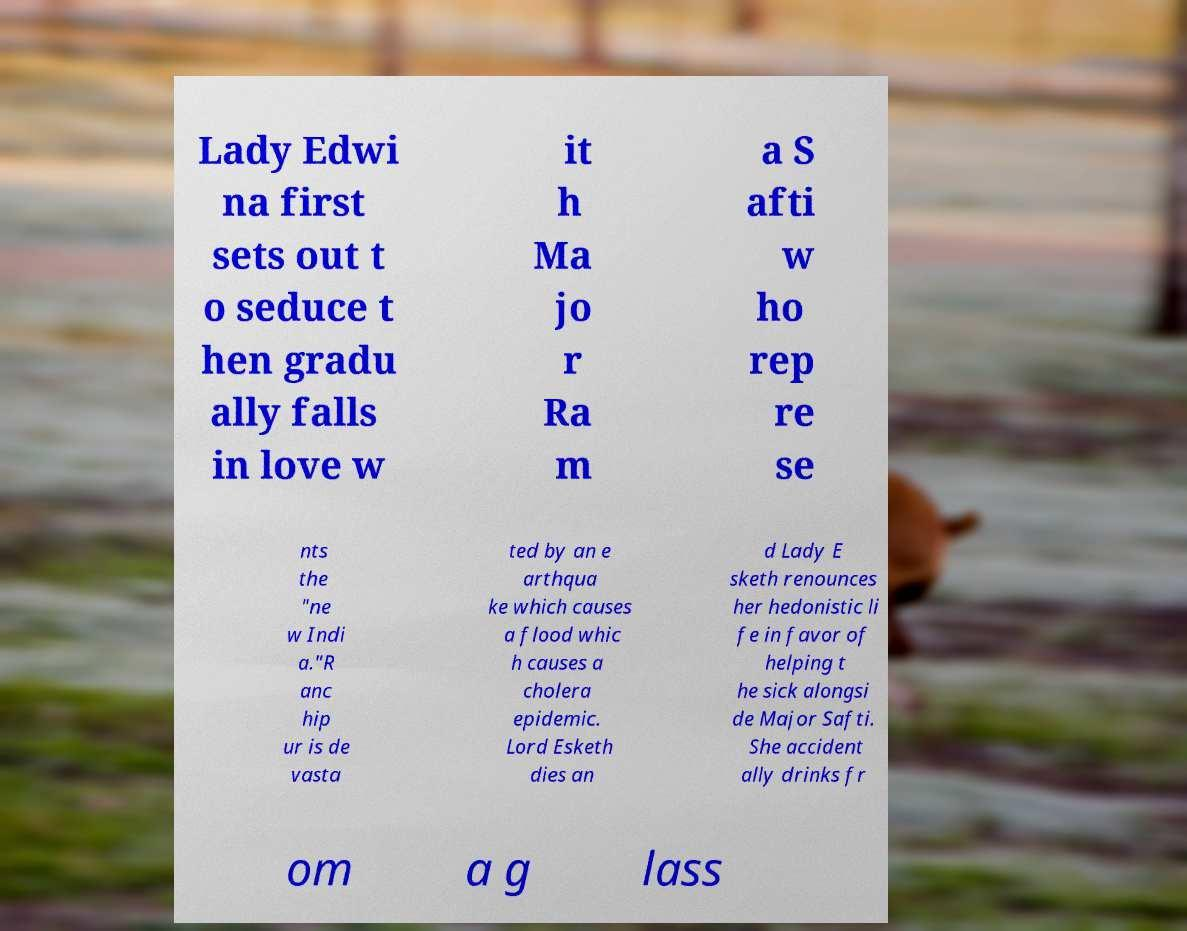There's text embedded in this image that I need extracted. Can you transcribe it verbatim? Lady Edwi na first sets out t o seduce t hen gradu ally falls in love w it h Ma jo r Ra m a S afti w ho rep re se nts the "ne w Indi a."R anc hip ur is de vasta ted by an e arthqua ke which causes a flood whic h causes a cholera epidemic. Lord Esketh dies an d Lady E sketh renounces her hedonistic li fe in favor of helping t he sick alongsi de Major Safti. She accident ally drinks fr om a g lass 